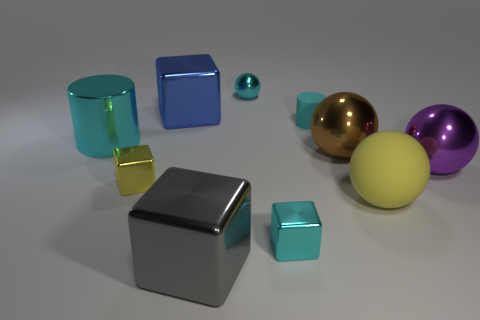There is another purple thing that is the same shape as the large matte thing; what material is it?
Make the answer very short. Metal. What number of other things are there of the same color as the small rubber cylinder?
Offer a very short reply. 3. There is a cube left of the blue cube behind the big cyan metallic object; what number of large metal spheres are behind it?
Give a very brief answer. 2. Are there fewer large things that are on the left side of the big brown thing than small yellow blocks that are behind the large purple ball?
Provide a short and direct response. No. How many other objects are the same material as the brown sphere?
Your response must be concise. 7. There is a brown thing that is the same size as the purple shiny object; what material is it?
Make the answer very short. Metal. What number of gray objects are big blocks or tiny matte cubes?
Provide a succinct answer. 1. There is a small metallic thing that is in front of the tiny matte object and right of the gray metallic thing; what is its color?
Your answer should be compact. Cyan. Is the blue object that is behind the yellow ball made of the same material as the yellow thing in front of the yellow shiny block?
Keep it short and to the point. No. Is the number of blue cubes in front of the small yellow thing greater than the number of brown shiny things that are in front of the large blue metallic cube?
Your answer should be very brief. No. 